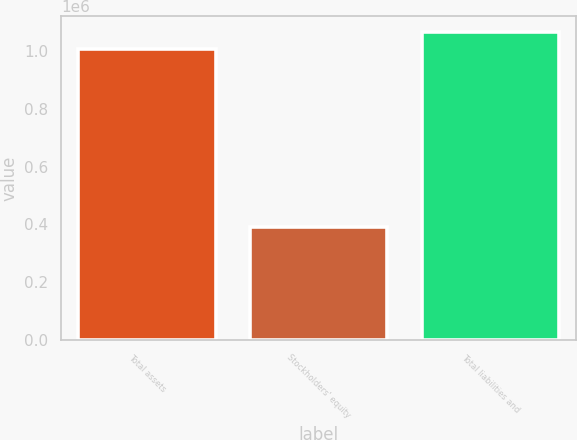Convert chart. <chart><loc_0><loc_0><loc_500><loc_500><bar_chart><fcel>Total assets<fcel>Stockholders' equity<fcel>Total liabilities and<nl><fcel>1.00703e+06<fcel>390722<fcel>1.06866e+06<nl></chart> 